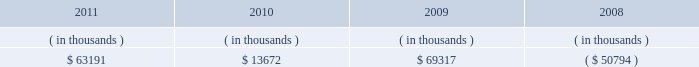Entergy texas , inc .
And subsidiaries management 2019s financial discussion and analysis also in addition to the contractual obligations , entergy texas has $ 7.2 million of unrecognized tax benefits and interest net of unused tax attributes and payments for which the timing of payments beyond 12 months cannot be reasonably estimated due to uncertainties in the timing of effective settlement of tax positions .
See note 3 to the financial statements for additional information regarding unrecognized tax benefits .
Entergy 2019s utility supply plan initiative will continue to seek to transform its generation portfolio with new or repowered generation resources .
Opportunities resulting from the supply plan initiative , including new projects or the exploration of alternative financing sources , could result in increases or decreases in the capital expenditure estimates given above .
The estimated capital expenditures are subject to periodic review and modification and may vary based on the ongoing effects of regulatory constraints , environmental compliance , market volatility , economic trends , business restructuring , changes in project plans , and the ability to access capital .
Management provides more information on long-term debt and preferred stock maturities in notes 5 and 6 to the financial statements .
As a wholly-owned subsidiary , entergy texas pays dividends to entergy corporation from its earnings at a percentage determined monthly .
Sources of capital entergy texas 2019s sources to meet its capital requirements include : internally generated funds ; cash on hand ; debt or preferred stock issuances ; and bank financing under new or existing facilities .
Entergy texas may refinance , redeem , or otherwise retire debt prior to maturity , to the extent market conditions and interest and dividend rates are favorable .
All debt and common and preferred stock issuances by entergy texas require prior regulatory approval .
Debt issuances are also subject to issuance tests set forth in its bond indentures and other agreements .
Entergy texas has sufficient capacity under these tests to meet its foreseeable capital needs .
Entergy texas 2019s receivables from or ( payables to ) the money pool were as follows as of december 31 for each of the following years: .
See note 4 to the financial statements for a description of the money pool .
Entergy texas has a credit facility in the amount of $ 100 million scheduled to expire in august 2012 .
No borrowings were outstanding under the facility as of december 31 , 2011 .
Entergy texas has obtained short-term borrowing authorization through october 2013 from the ferc under which it may borrow at any one time outstanding , $ 200 million in the aggregate .
See note 4 to the financial statements for further discussion of entergy texas 2019s short-term borrowing limits .
Entergy texas has also obtained an order from the ferc authorizing long-term securities issuances through july 2013 .
Hurricane ike and hurricane gustav in september 2008 , hurricane ike caused catastrophic damage to entergy texas 2019s service territory .
The storm resulted in widespread power outages , significant damage to distribution , transmission , and generation infrastructure , and the loss of sales during the power outages .
Entergy texas filed an application in april 2009 seeking a determination that $ 577.5 million of hurricane ike and hurricane gustav restoration costs are recoverable .
What was the sum of entergy texas 2019s receivable from 2008 to 2011 in millions? 
Computations: (69317 + (63191 + 13672))
Answer: 146180.0. 